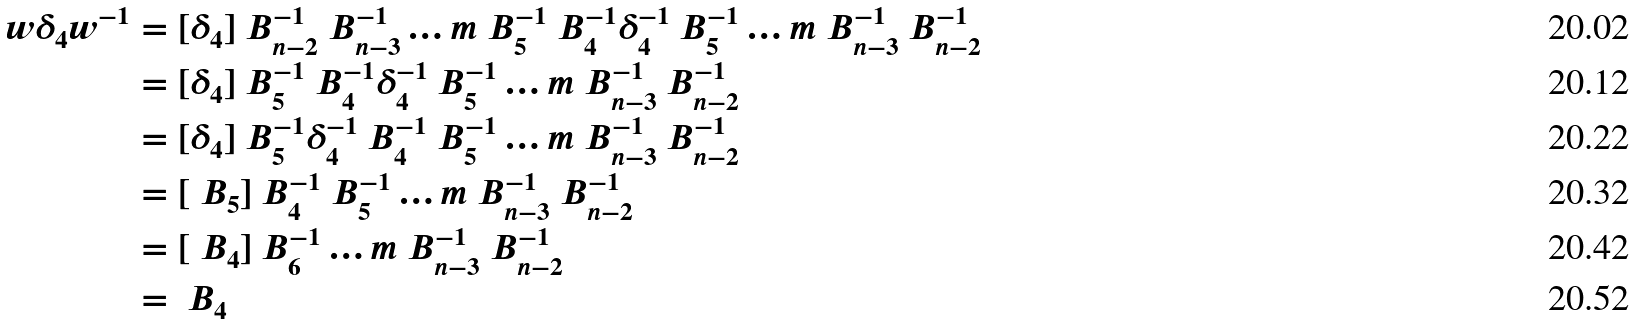Convert formula to latex. <formula><loc_0><loc_0><loc_500><loc_500>w \delta _ { 4 } w ^ { - 1 } & = [ \delta _ { 4 } ] \ B _ { n - 2 } ^ { - 1 } \ B _ { n - 3 } ^ { - 1 } \dots m \ B _ { 5 } ^ { - 1 } \ B _ { 4 } ^ { - 1 } \delta _ { 4 } ^ { - 1 } \ B _ { 5 } ^ { - 1 } \dots m \ B _ { n - 3 } ^ { - 1 } \ B _ { n - 2 } ^ { - 1 } \\ & = [ \delta _ { 4 } ] \ B _ { 5 } ^ { - 1 } \ B _ { 4 } ^ { - 1 } \delta _ { 4 } ^ { - 1 } \ B _ { 5 } ^ { - 1 } \dots m \ B _ { n - 3 } ^ { - 1 } \ B _ { n - 2 } ^ { - 1 } \\ & = [ \delta _ { 4 } ] \ B _ { 5 } ^ { - 1 } \delta _ { 4 } ^ { - 1 } \ B _ { 4 } ^ { - 1 } \ B _ { 5 } ^ { - 1 } \dots m \ B _ { n - 3 } ^ { - 1 } \ B _ { n - 2 } ^ { - 1 } \\ & = [ \ B _ { 5 } ] \ B _ { 4 } ^ { - 1 } \ B _ { 5 } ^ { - 1 } \dots m \ B _ { n - 3 } ^ { - 1 } \ B _ { n - 2 } ^ { - 1 } \\ & = [ \ B _ { 4 } ] \ B _ { 6 } ^ { - 1 } \dots m \ B _ { n - 3 } ^ { - 1 } \ B _ { n - 2 } ^ { - 1 } \\ & = \ B _ { 4 }</formula> 